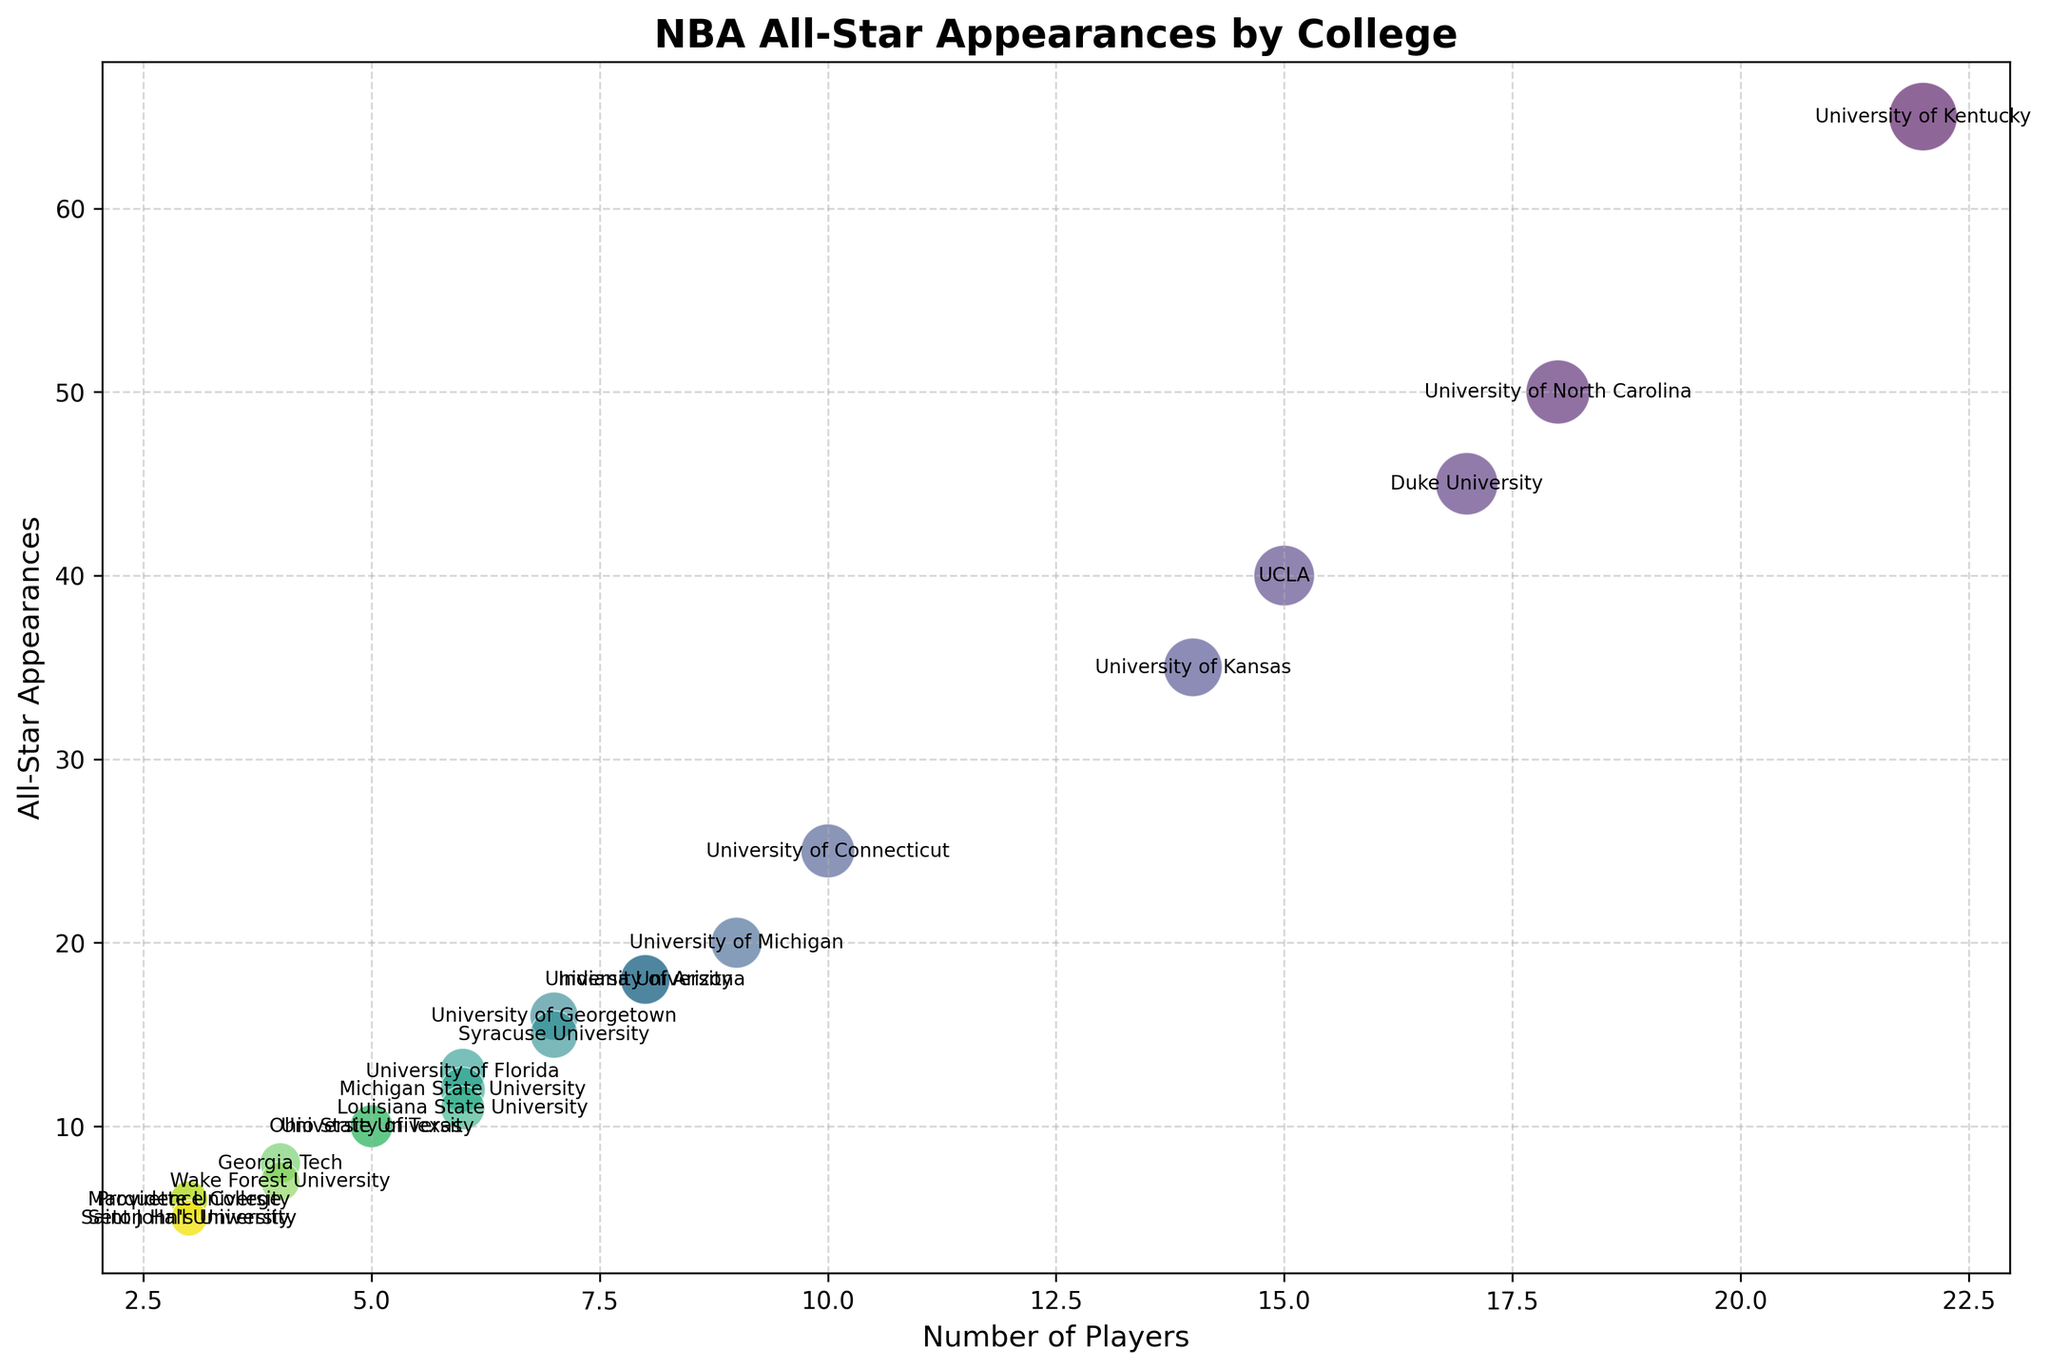What college has produced the highest number of NBA All-Star appearances? The largest bubble indicates the college with the highest number of All-Star appearances. The University of Kentucky has the largest bubble, indicating it has produced the most All-Star appearances.
Answer: University of Kentucky Which two colleges have produced an equal number of All-Star appearances but differ in the number of players? Look for bubbles that are at the same height (indicating the same number of All-Star appearances) but have different horizontal positions (indicating different player counts). Indiana University and University of Arizona both have 18 All-Star appearances but different player counts.
Answer: Indiana University and University of Arizona How many more All-Star appearances does Duke University have than the University of Texas? First, find the All-Star appearances for each (Duke University - 45, University of Texas - 10) and then subtract the smaller from the larger. Duke University has 35 more All-Star appearances than the University of Texas.
Answer: 35 What is the average number of All-Star appearances among colleges with exactly 5 players? Find all colleges with 5 players and then calculate the average of their All-Star appearances: Ohio State University (10) and University of Texas (10). The average is (10 + 10) / 2 = 10.
Answer: 10 Which college with 7 players has more All-Star appearances, Syracuse University or University of Georgetown? Compare the heights of the bubbles corresponding to 7 players. Syracuse University has 15 All-Star appearances while University of Georgetown has 16. Thus, University of Georgetown has more.
Answer: University of Georgetown How many colleges have produced more than 40 All-Star appearances? Count the number of colleges with bubbles positioned above the 40 All-Star appearances line. Universities that qualify are University of Kentucky (65), University of North Carolina (50), and Duke University (45). So there are 3 colleges.
Answer: 3 Which college has the second-largest bubble size and what does it represent? Identify the second-largest bubble visually or by identifying the college with the second-highest All-Star appearances. University of North Carolina has the second-largest bubble, representing 50 All-Star appearances.
Answer: University of North Carolina, 50 What is the player count range for colleges producing between 10 and 20 All-Star appearances? Identify the horizontal range for bubbles positioned between 10 and 20 All-Star appearances. Colleges in this range have player counts from 3 (Seton Hall University) to 9 (University of Michigan).
Answer: 3 to 9 Which college with 4 players has the highest number of All-Star appearances? Identify the college among those with 4 players by comparing bubble heights. Georgia Tech has 8 All-Star appearances, and Wake Forest University has 7 All-Star appearances. Therefore, Georgia Tech has the highest.
Answer: Georgia Tech 